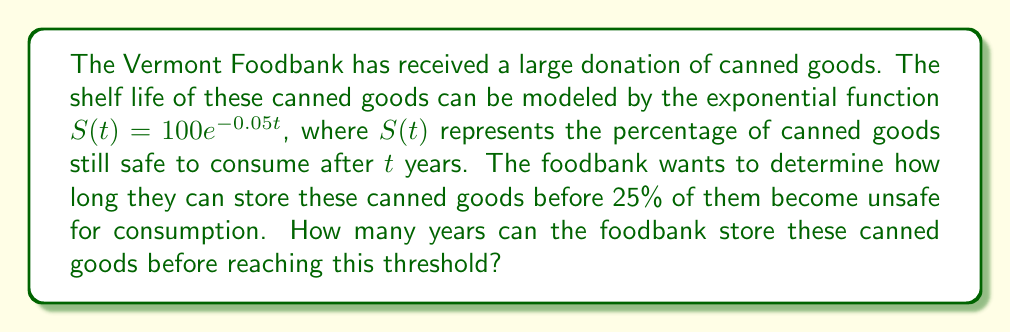Give your solution to this math problem. To solve this problem, we need to use the given exponential function and find the time $t$ when $S(t) = 25$. Let's approach this step-by-step:

1) We start with the equation:
   $S(t) = 100e^{-0.05t}$

2) We want to find $t$ when $S(t) = 25$, so we set up the equation:
   $25 = 100e^{-0.05t}$

3) Divide both sides by 100:
   $0.25 = e^{-0.05t}$

4) Take the natural logarithm of both sides:
   $\ln(0.25) = \ln(e^{-0.05t})$

5) Simplify the right side using the properties of logarithms:
   $\ln(0.25) = -0.05t$

6) Solve for $t$:
   $t = -\frac{\ln(0.25)}{0.05}$

7) Calculate the value:
   $t = -\frac{\ln(0.25)}{0.05} \approx 27.73$ years

Therefore, the Vermont Foodbank can store the canned goods for approximately 27.73 years before 25% of them become unsafe for consumption.
Answer: $27.73$ years 